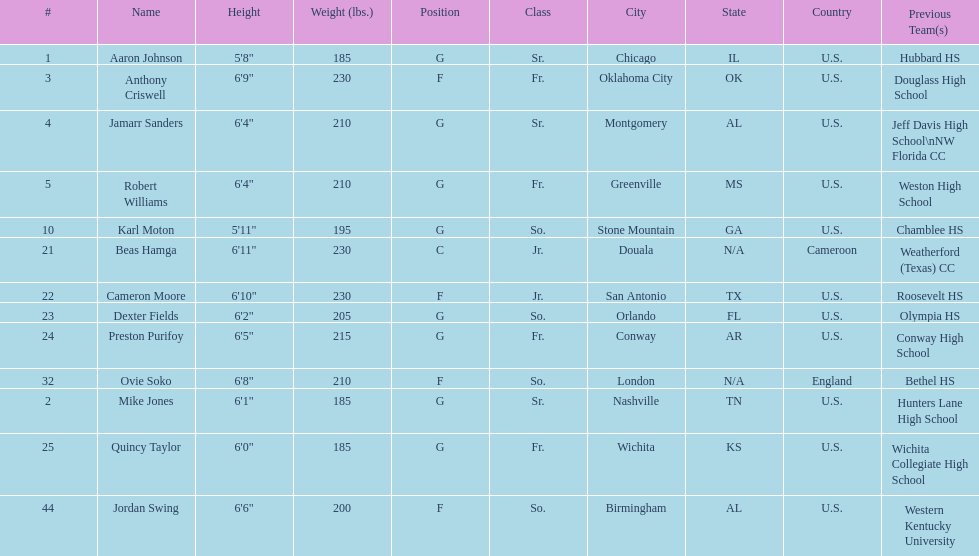Other than soko, tell me a player who is not from the us. Beas Hamga. 